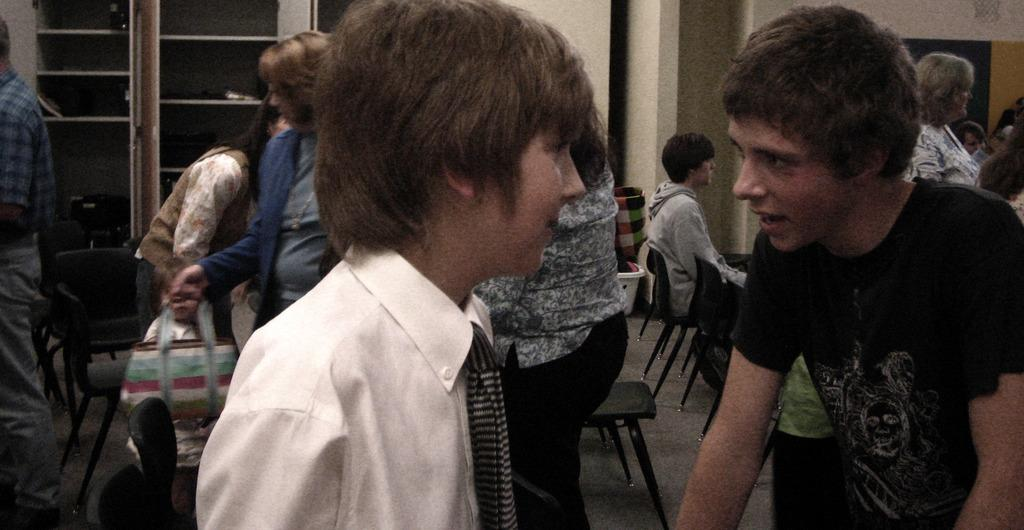Who or what can be seen in the image? There are people in the image. What are the people sitting on in the image? There are chairs in the image. What is the purpose of the basket in the image? The purpose of the basket is not specified in the facts, but it is present in the image. What can be seen in the background of the image? There are objects in racks and a wall visible in the background of the image. How does the person in the image feel about their recent loss? There is no indication of a loss or any emotions related to it in the image. 